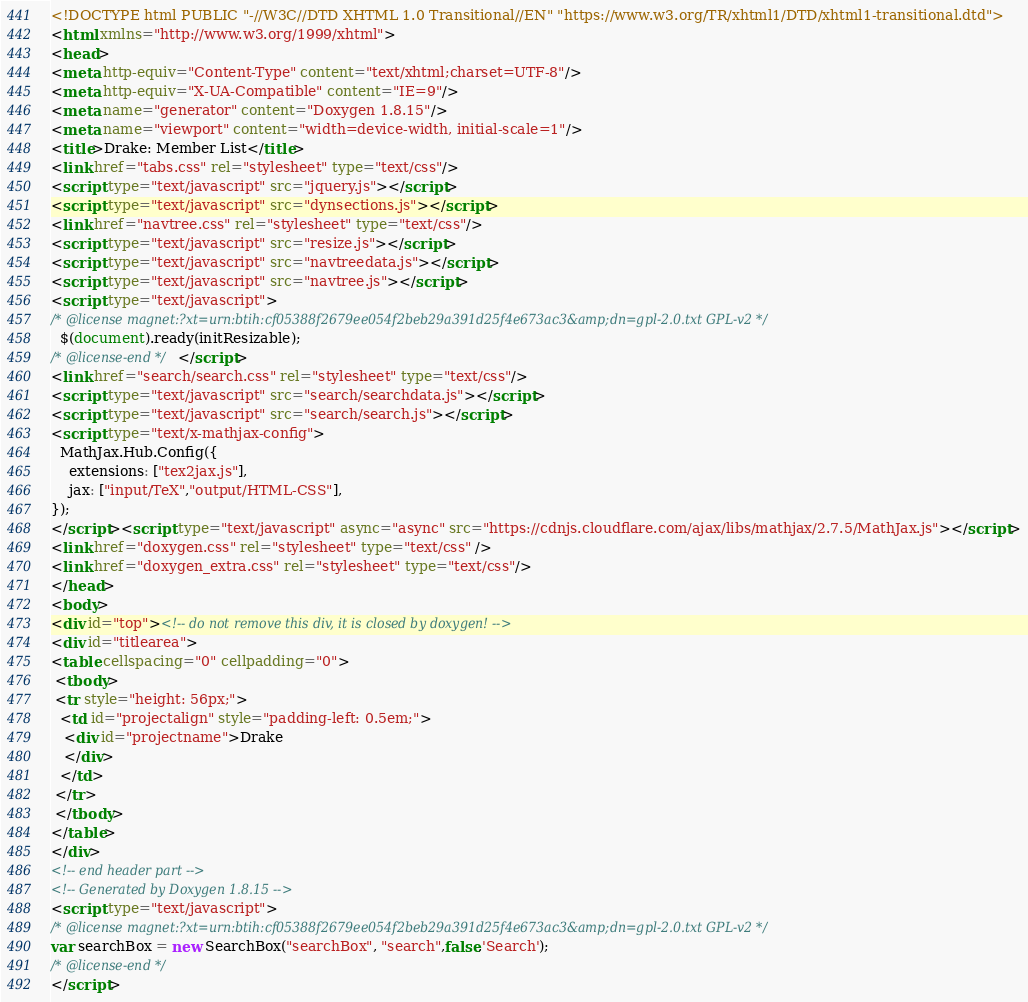<code> <loc_0><loc_0><loc_500><loc_500><_HTML_><!DOCTYPE html PUBLIC "-//W3C//DTD XHTML 1.0 Transitional//EN" "https://www.w3.org/TR/xhtml1/DTD/xhtml1-transitional.dtd">
<html xmlns="http://www.w3.org/1999/xhtml">
<head>
<meta http-equiv="Content-Type" content="text/xhtml;charset=UTF-8"/>
<meta http-equiv="X-UA-Compatible" content="IE=9"/>
<meta name="generator" content="Doxygen 1.8.15"/>
<meta name="viewport" content="width=device-width, initial-scale=1"/>
<title>Drake: Member List</title>
<link href="tabs.css" rel="stylesheet" type="text/css"/>
<script type="text/javascript" src="jquery.js"></script>
<script type="text/javascript" src="dynsections.js"></script>
<link href="navtree.css" rel="stylesheet" type="text/css"/>
<script type="text/javascript" src="resize.js"></script>
<script type="text/javascript" src="navtreedata.js"></script>
<script type="text/javascript" src="navtree.js"></script>
<script type="text/javascript">
/* @license magnet:?xt=urn:btih:cf05388f2679ee054f2beb29a391d25f4e673ac3&amp;dn=gpl-2.0.txt GPL-v2 */
  $(document).ready(initResizable);
/* @license-end */</script>
<link href="search/search.css" rel="stylesheet" type="text/css"/>
<script type="text/javascript" src="search/searchdata.js"></script>
<script type="text/javascript" src="search/search.js"></script>
<script type="text/x-mathjax-config">
  MathJax.Hub.Config({
    extensions: ["tex2jax.js"],
    jax: ["input/TeX","output/HTML-CSS"],
});
</script><script type="text/javascript" async="async" src="https://cdnjs.cloudflare.com/ajax/libs/mathjax/2.7.5/MathJax.js"></script>
<link href="doxygen.css" rel="stylesheet" type="text/css" />
<link href="doxygen_extra.css" rel="stylesheet" type="text/css"/>
</head>
<body>
<div id="top"><!-- do not remove this div, it is closed by doxygen! -->
<div id="titlearea">
<table cellspacing="0" cellpadding="0">
 <tbody>
 <tr style="height: 56px;">
  <td id="projectalign" style="padding-left: 0.5em;">
   <div id="projectname">Drake
   </div>
  </td>
 </tr>
 </tbody>
</table>
</div>
<!-- end header part -->
<!-- Generated by Doxygen 1.8.15 -->
<script type="text/javascript">
/* @license magnet:?xt=urn:btih:cf05388f2679ee054f2beb29a391d25f4e673ac3&amp;dn=gpl-2.0.txt GPL-v2 */
var searchBox = new SearchBox("searchBox", "search",false,'Search');
/* @license-end */
</script></code> 